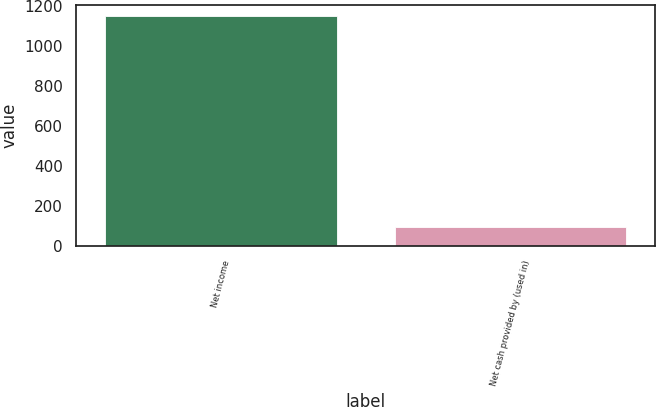Convert chart. <chart><loc_0><loc_0><loc_500><loc_500><bar_chart><fcel>Net income<fcel>Net cash provided by (used in)<nl><fcel>1149<fcel>95<nl></chart> 